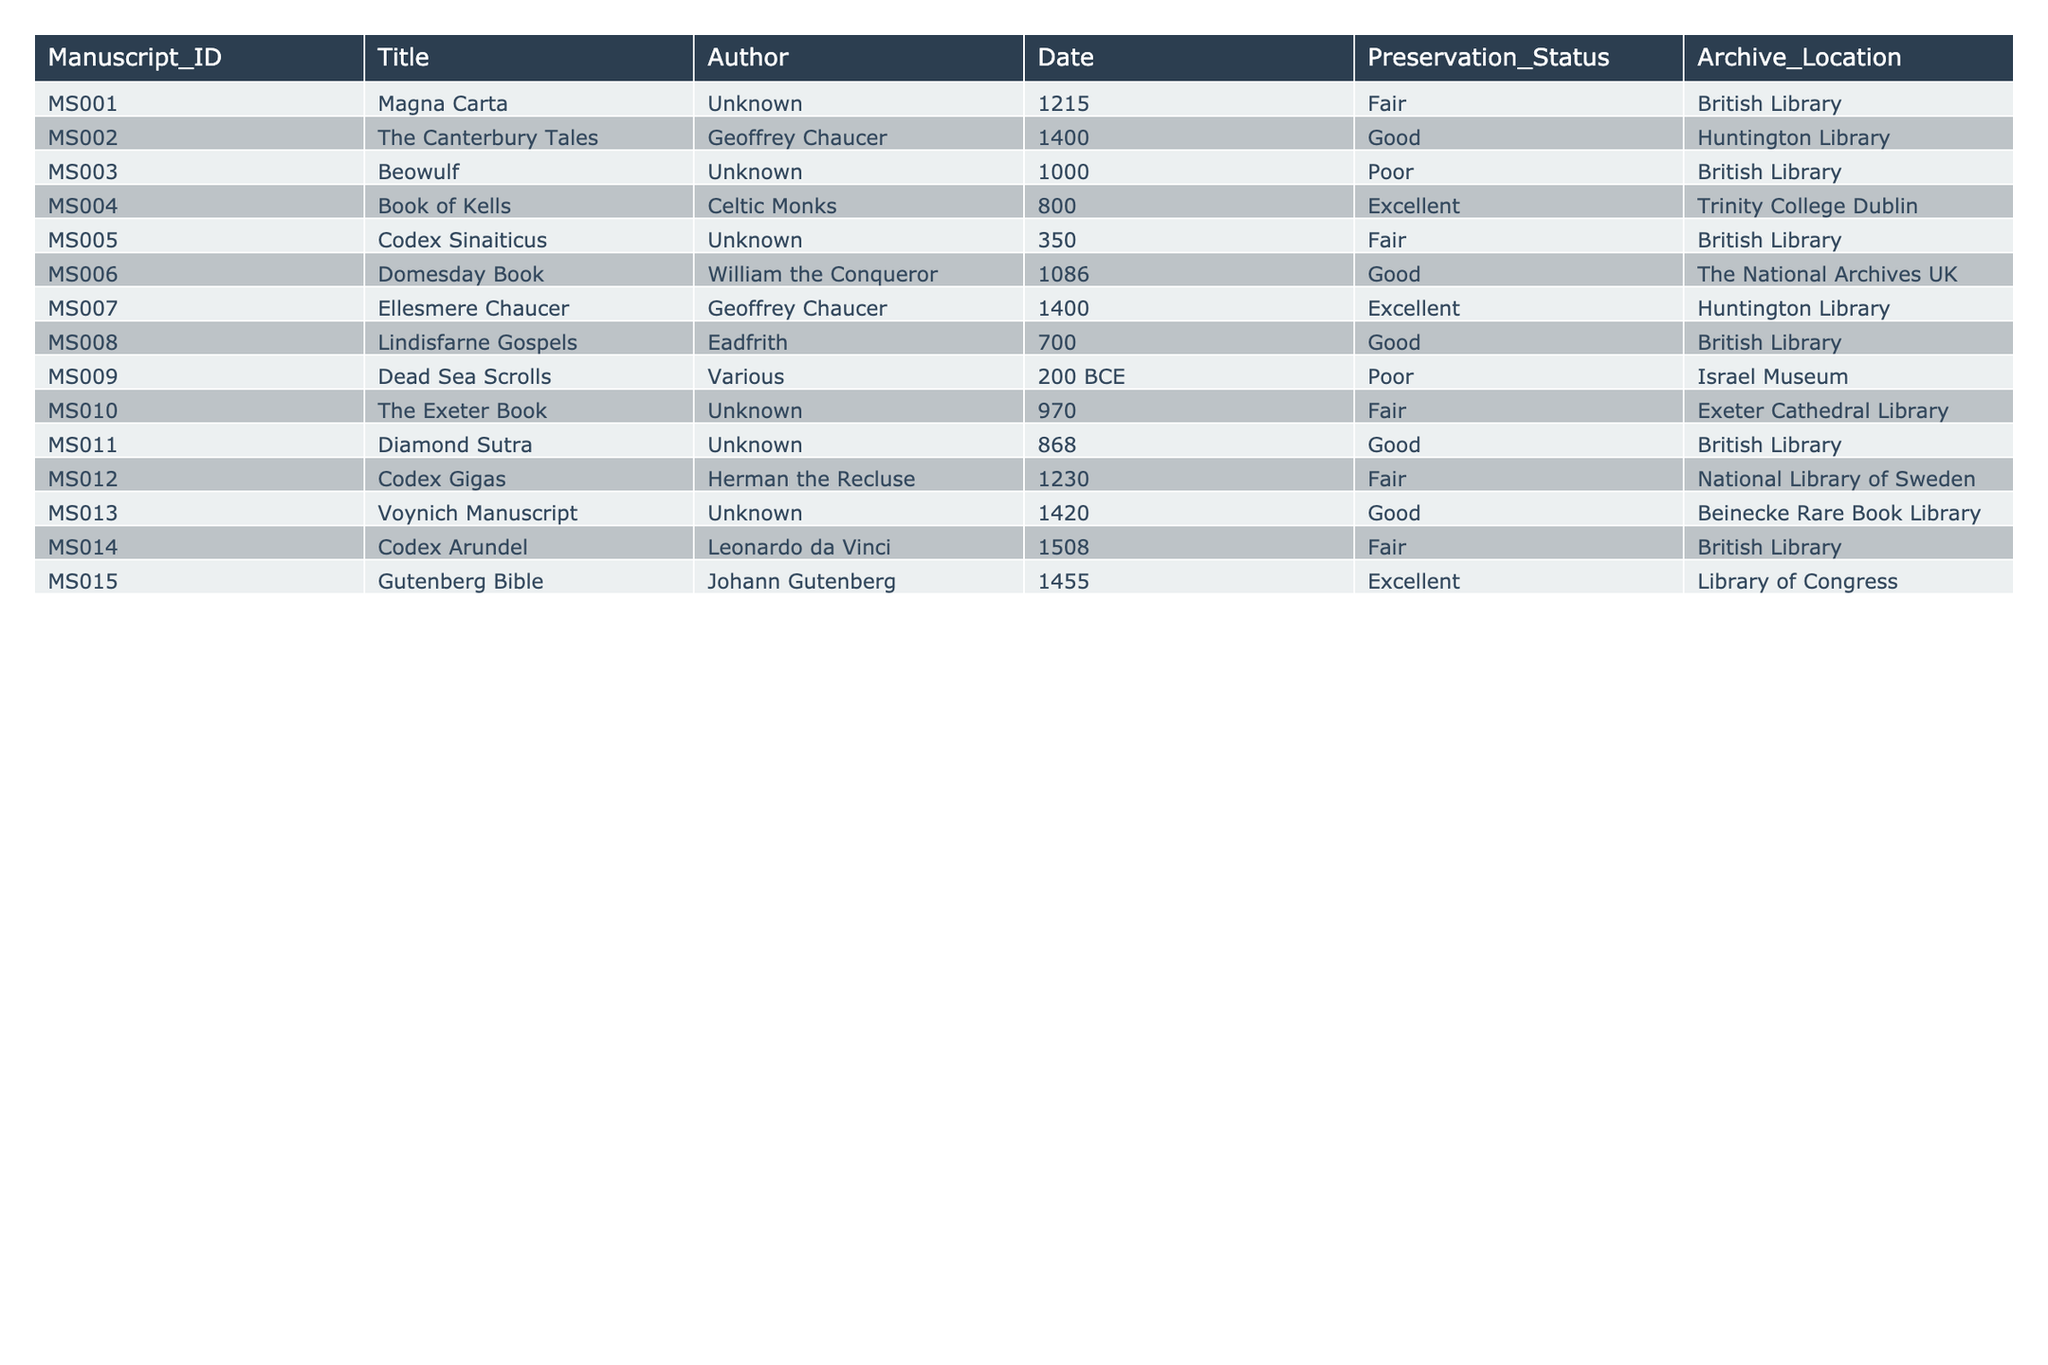What is the preservation status of the Codex Sinaiticus? Referring to the table, the preservation status listed for the Codex Sinaiticus is "Fair."
Answer: Fair Who is the author of the Great Bible? The table does not list any manuscript titled "Great Bible," therefore, there is no corresponding author.
Answer: Not applicable How many manuscripts have a preservation status of "Excellent"? The table shows there are 3 manuscripts with a preservation status of "Excellent": the Book of Kells, Gutenberg Bible, and Ellesmere Chaucer.
Answer: 3 Which manuscript was created in the year 1215? From the table, the manuscript created in the year 1215 is the Magna Carta.
Answer: Magna Carta Is the author of the Dead Sea Scrolls listed in the table? The table indicates that the author of the Dead Sea Scrolls is categorized as "Various," meaning no single author is specified.
Answer: Yes What is the earliest manuscript listed in the table? The earliest manuscript is Beowulf from the year 1000, as other entries with earlier dates are not present.
Answer: Beowulf Which archive has the most manuscripts recorded in the table? By counting the entries, the British Library has 5 manuscripts listed, more than any other archive location.
Answer: British Library List the titles of manuscripts authored by Geoffrey Chaucer. The titles authored by Geoffrey Chaucer in the table are The Canterbury Tales and Ellesmere Chaucer.
Answer: The Canterbury Tales, Ellesmere Chaucer What is the average year of creation for manuscripts with a "Good" preservation status? To calculate: (1400 + 1086 + 700 + 868 + 1420 + 1455) = 5430. There are 6 manuscripts, so the average year is 5430 / 6 = 905.
Answer: 905 Are there any manuscripts authored by unknown authors that have "Poor" preservation status? Yes, both Beowulf and the Dead Sea Scrolls are authored by unknowns and are marked as "Poor" in preservation status.
Answer: Yes What percentage of manuscripts in the table have a preservation status categorized as "Fair"? The table includes 15 manuscripts, with 4 marked as "Fair." Therefore, the percentage is (4/15) * 100 = 26.67%.
Answer: 26.67% Compare the number of manuscripts in "Poor" preservation status to those in "Good" status. The table shows 3 manuscripts in "Poor" status and 5 in "Good," indicating that there are more good-quality manuscripts.
Answer: More in "Good" status What location has the least number of manuscripts recorded in the table? By reviewing the table entries, the location with only one manuscript is the Exeter Cathedral Library.
Answer: Exeter Cathedral Library Which manuscript(s) listed have an author as "Unknown" and are in "Fair" condition? The Codex Sinaiticus and The Exeter Book are both authored by "Unknown" and listed as "Fair" in preservation status.
Answer: Codex Sinaiticus, The Exeter Book Identify the most recent manuscript entry and its preservation status. The most recent manuscript is the Gutenberg Bible from 1455, which has an "Excellent" preservation status.
Answer: Gutenberg Bible, Excellent 